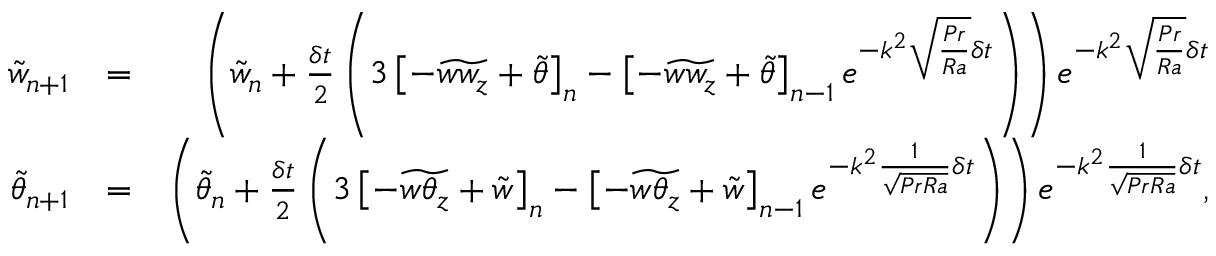Convert formula to latex. <formula><loc_0><loc_0><loc_500><loc_500>\begin{array} { r l r } { \tilde { w } _ { n + 1 } } & { = } & { \left ( \tilde { w } _ { n } + \frac { \delta t } { 2 } \left ( 3 \left [ - \widetilde { w w _ { z } } + \tilde { \theta } \right ] _ { n } - \left [ - \widetilde { w w _ { z } } + \tilde { \theta } \right ] _ { n - 1 } e ^ { - k ^ { 2 } \sqrt { \frac { P r } { R a } } \delta t } \right ) \right ) e ^ { - k ^ { 2 } \sqrt { \frac { P r } { R a } } \delta t } } \\ { \tilde { \theta } _ { n + 1 } } & { = } & { \left ( \tilde { \theta } _ { n } + \frac { \delta t } { 2 } \left ( 3 \left [ - \widetilde { w \theta _ { z } } + \tilde { w } \right ] _ { n } - \left [ - \widetilde { w \theta _ { z } } + \tilde { w } \right ] _ { n - 1 } e ^ { - k ^ { 2 } \frac { 1 } { \sqrt { P r R a } } \delta t } \right ) \right ) e ^ { - k ^ { 2 } \frac { 1 } { \sqrt { P r R a } } \delta t } , } \end{array}</formula> 